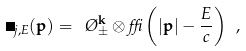Convert formula to latex. <formula><loc_0><loc_0><loc_500><loc_500>\Phi _ { j , E } ( { \mathbf p } ) = \ \chi _ { \pm } ^ { \mathbf k } \otimes \delta \left ( | { \mathbf p } | - \frac { E } { c } \right ) \ ,</formula> 